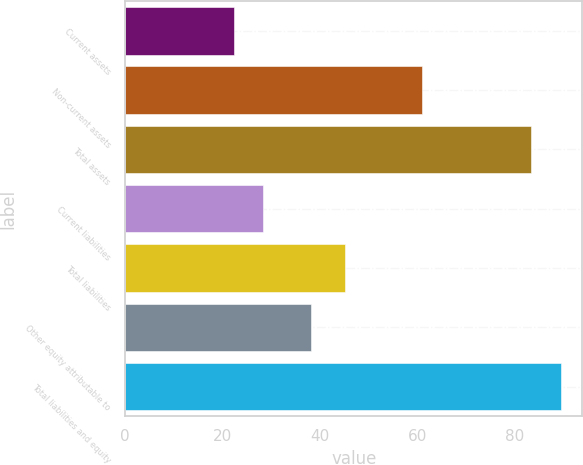<chart> <loc_0><loc_0><loc_500><loc_500><bar_chart><fcel>Current assets<fcel>Non-current assets<fcel>Total assets<fcel>Current liabilities<fcel>Total liabilities<fcel>Other equity attributable to<fcel>Total liabilities and equity<nl><fcel>22.3<fcel>61<fcel>83.3<fcel>28.4<fcel>45.1<fcel>38.2<fcel>89.4<nl></chart> 